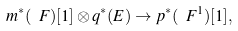Convert formula to latex. <formula><loc_0><loc_0><loc_500><loc_500>m ^ { * } ( \ F ) [ 1 ] \otimes q ^ { * } ( E ) \to p ^ { * } ( \ F ^ { 1 } ) [ 1 ] ,</formula> 